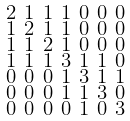Convert formula to latex. <formula><loc_0><loc_0><loc_500><loc_500>\begin{smallmatrix} 2 & 1 & 1 & 1 & 0 & 0 & 0 \\ 1 & 2 & 1 & 1 & 0 & 0 & 0 \\ 1 & 1 & 2 & 1 & 0 & 0 & 0 \\ 1 & 1 & 1 & 3 & 1 & 1 & 0 \\ 0 & 0 & 0 & 1 & 3 & 1 & 1 \\ 0 & 0 & 0 & 1 & 1 & 3 & 0 \\ 0 & 0 & 0 & 0 & 1 & 0 & 3 \end{smallmatrix}</formula> 